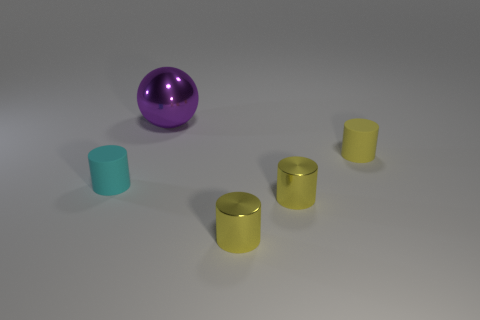How many other objects are the same shape as the big metal object?
Keep it short and to the point. 0. What color is the other rubber thing that is the same size as the cyan thing?
Give a very brief answer. Yellow. How many cylinders are either yellow matte objects or small cyan objects?
Your answer should be compact. 2. How many tiny rubber objects are there?
Keep it short and to the point. 2. There is a yellow rubber thing; is its shape the same as the small rubber thing that is to the left of the big object?
Provide a short and direct response. Yes. What number of objects are either large metal things or tiny cyan metal cubes?
Make the answer very short. 1. What shape is the metallic object behind the tiny matte thing that is to the right of the big purple metal ball?
Provide a short and direct response. Sphere. Does the matte object that is right of the small cyan matte thing have the same shape as the small cyan matte thing?
Ensure brevity in your answer.  Yes. There is a yellow cylinder that is made of the same material as the tiny cyan cylinder; what size is it?
Provide a short and direct response. Small. What number of things are objects on the left side of the purple metallic ball or rubber things to the left of the yellow rubber cylinder?
Your answer should be very brief. 1. 